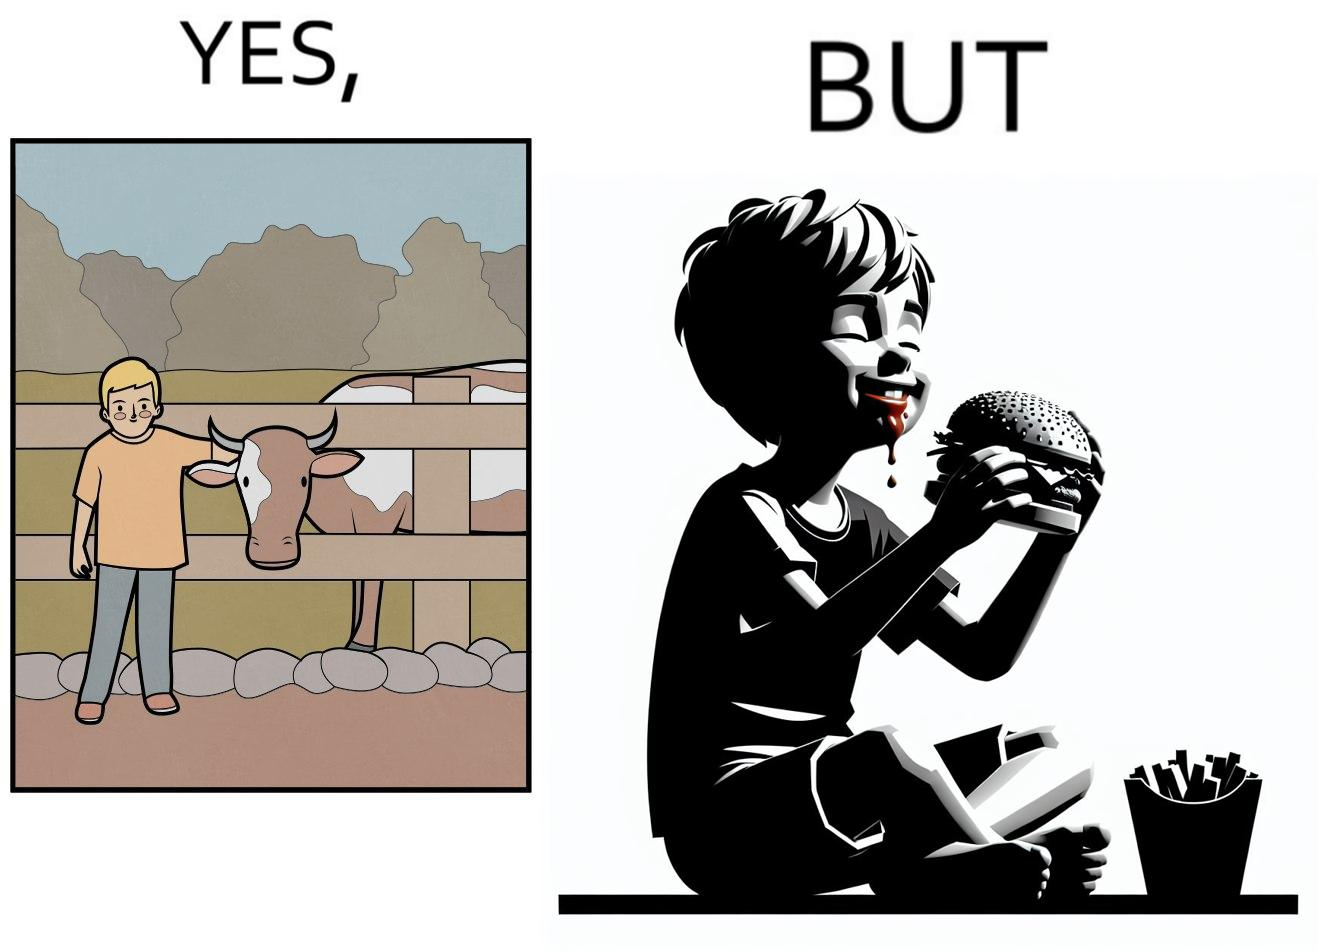Explain the humor or irony in this image. The irony is that the boy is petting the cow to show that he cares about the animal, but then he also eats hamburgers made from the same cows 